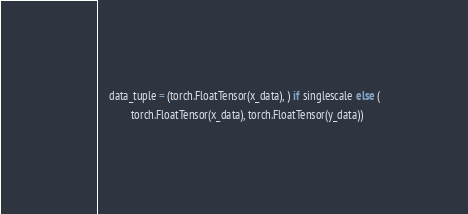<code> <loc_0><loc_0><loc_500><loc_500><_Python_>    data_tuple = (torch.FloatTensor(x_data), ) if singlescale else (
            torch.FloatTensor(x_data), torch.FloatTensor(y_data))</code> 